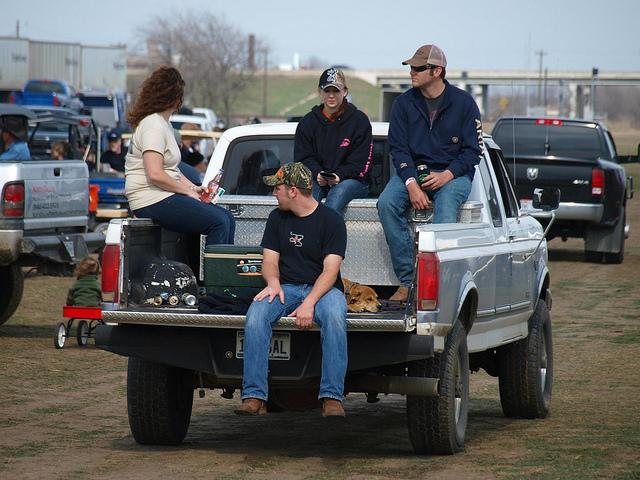What is the name for this sort of event? Please explain your reasoning. tailgate. People using the back of their trucks for entertainment area. 